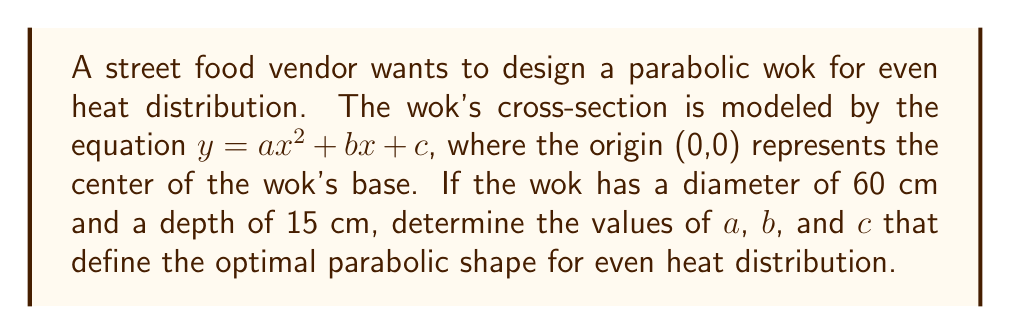Can you answer this question? Let's approach this step-by-step:

1) Given the wok's dimensions, we know that:
   - The width is 60 cm, so the radius is 30 cm.
   - The depth is 15 cm.

2) We can use these points to set up our equation:
   - At the center: (0, 0)
   - At the edge: (30, 15)

3) Since the parabola is symmetrical, we know that $b = 0$ (no x-term).

4) Our equation becomes: $y = ax^2 + c$

5) We can now use our known points:
   - At (0, 0): $0 = a(0)^2 + c$, so $c = 0$
   - At (30, 15): $15 = a(30)^2 + 0$

6) Solving for $a$:
   $15 = 900a$
   $a = \frac{15}{900} = \frac{1}{60} \approx 0.0167$

7) Therefore, our parabolic equation is:

   $$y = \frac{1}{60}x^2$$

8) To verify, let's check the midpoint (15, 7.5):
   $7.5 = \frac{1}{60}(15)^2 = \frac{225}{60} = 3.75$

   This confirms that our parabola passes through the midpoint as expected.

[asy]
import graph;
size(200,100);
real f(real x) {return (1/60)*x^2;}
draw(graph(f,-30,30));
draw((-30,0)--(30,0),arrow=Arrow(TeXHead));
draw((0,0)--(0,15),arrow=Arrow(TeXHead));
label("x",(30,0),E);
label("y",(0,15),N);
dot((0,0));
dot((30,15));
dot((-30,15));
label("(30,15)",(30,15),NE);
label("(-30,15)",(-30,15),NW);
[/asy]
Answer: $a = \frac{1}{60}$, $b = 0$, $c = 0$ 